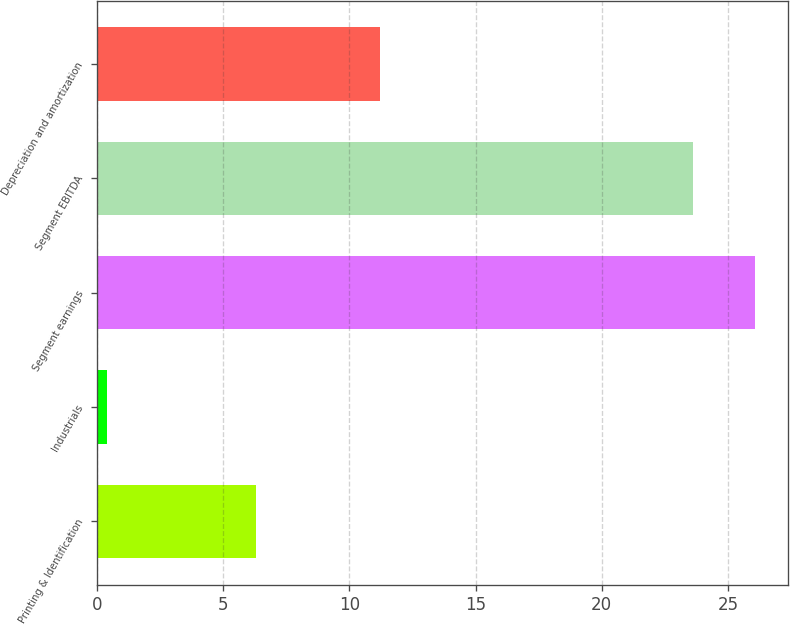Convert chart to OTSL. <chart><loc_0><loc_0><loc_500><loc_500><bar_chart><fcel>Printing & Identification<fcel>Industrials<fcel>Segment earnings<fcel>Segment EBITDA<fcel>Depreciation and amortization<nl><fcel>6.3<fcel>0.4<fcel>26.09<fcel>23.6<fcel>11.2<nl></chart> 